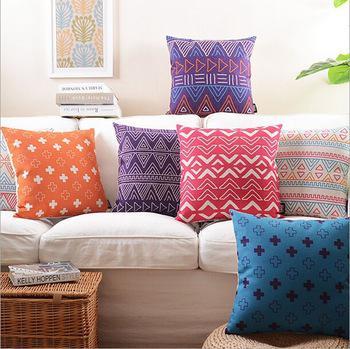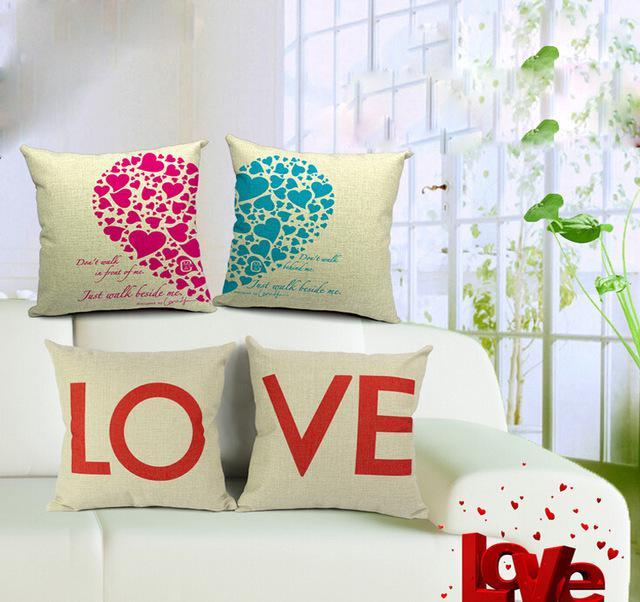The first image is the image on the left, the second image is the image on the right. For the images displayed, is the sentence "At least one colorful pillow is displayed in front of a wall featuring round decorative items." factually correct? Answer yes or no. No. The first image is the image on the left, the second image is the image on the right. Examine the images to the left and right. Is the description "A white window is visible in the right image." accurate? Answer yes or no. Yes. 